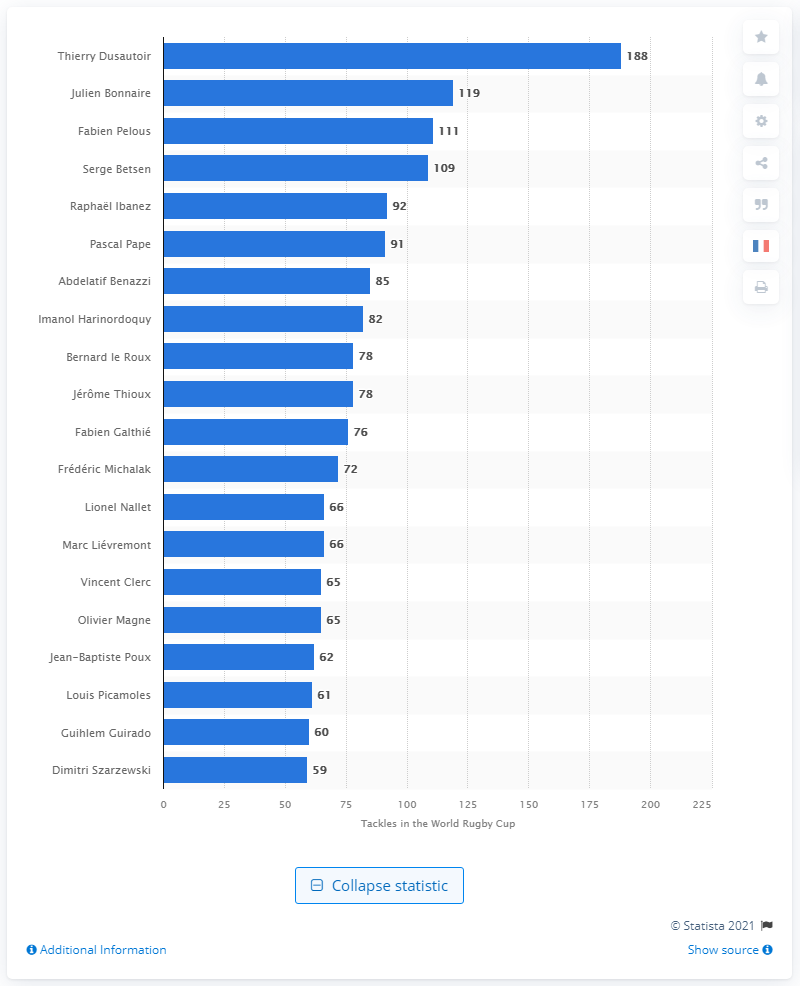Outline some significant characteristics in this image. Julien Bonnaire, a French rugby player, made the most tackles at the 2011 Rugby World Cup. Thierry Dusautoir holds the record for the most tackles made at the Rugby World Cup, making him a standout player in the history of the tournament. 